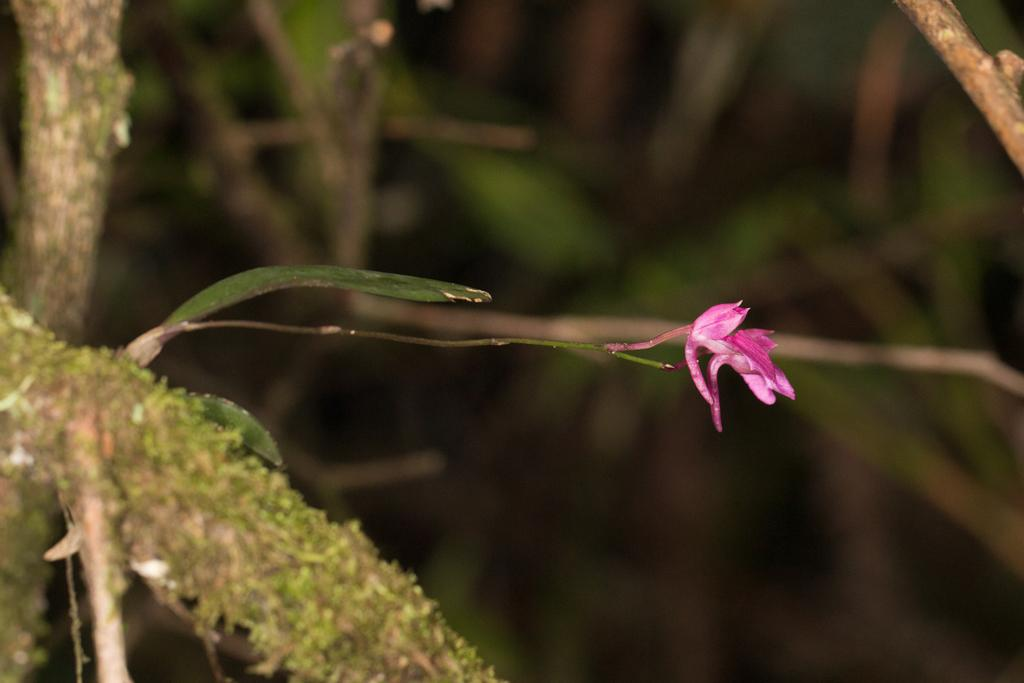What is the main subject of the image? There is a flower in the image. Can you describe the color of the flower? The flower is pink in color. What can be seen in the background of the image? There are branches visible in the background of the image. How many muscles can be seen in the image? There are no muscles visible in the image; it features a pink flower and branches in the background. Are there any bikes present in the image? There are no bikes present in the image; it features a pink flower and branches in the background. 